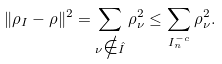<formula> <loc_0><loc_0><loc_500><loc_500>\| \rho _ { I } - \rho \| ^ { 2 } = \sum _ { \nu \notin \hat { I } } \rho _ { \nu } ^ { 2 } \leq \sum _ { I _ { n } ^ { - c } } \rho _ { \nu } ^ { 2 } .</formula> 